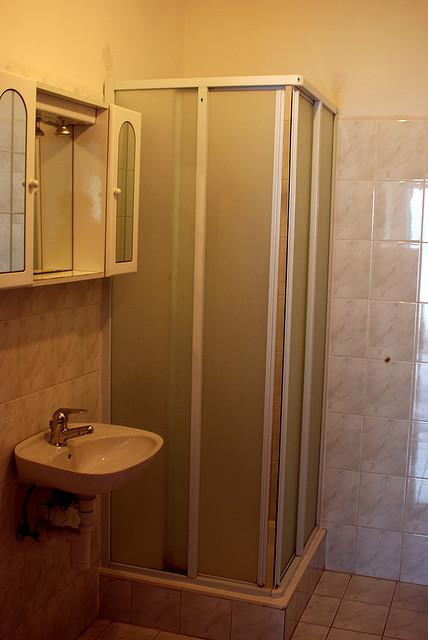Is there a tub shower combination in this image?
Keep it brief. No. Is the shower door open or closed?
Short answer required. Closed. What kind of flooring is in the bathroom?
Be succinct. Tile. What's in the cabinet?
Answer briefly. Nothing. Should there be a shower curtain?
Be succinct. No. 